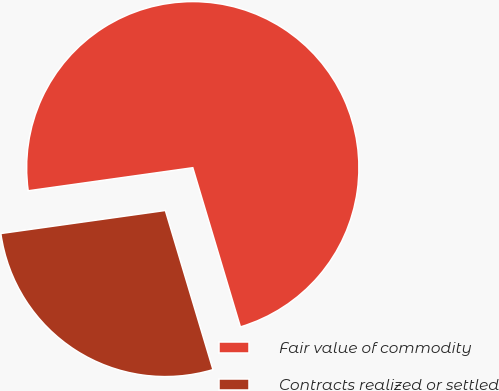Convert chart. <chart><loc_0><loc_0><loc_500><loc_500><pie_chart><fcel>Fair value of commodity<fcel>Contracts realized or settled<nl><fcel>72.59%<fcel>27.41%<nl></chart> 